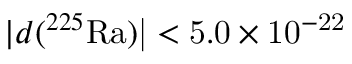<formula> <loc_0><loc_0><loc_500><loc_500>| d ( ^ { 2 2 5 } { R a } ) | < 5 . 0 \times 1 0 ^ { - 2 2 }</formula> 